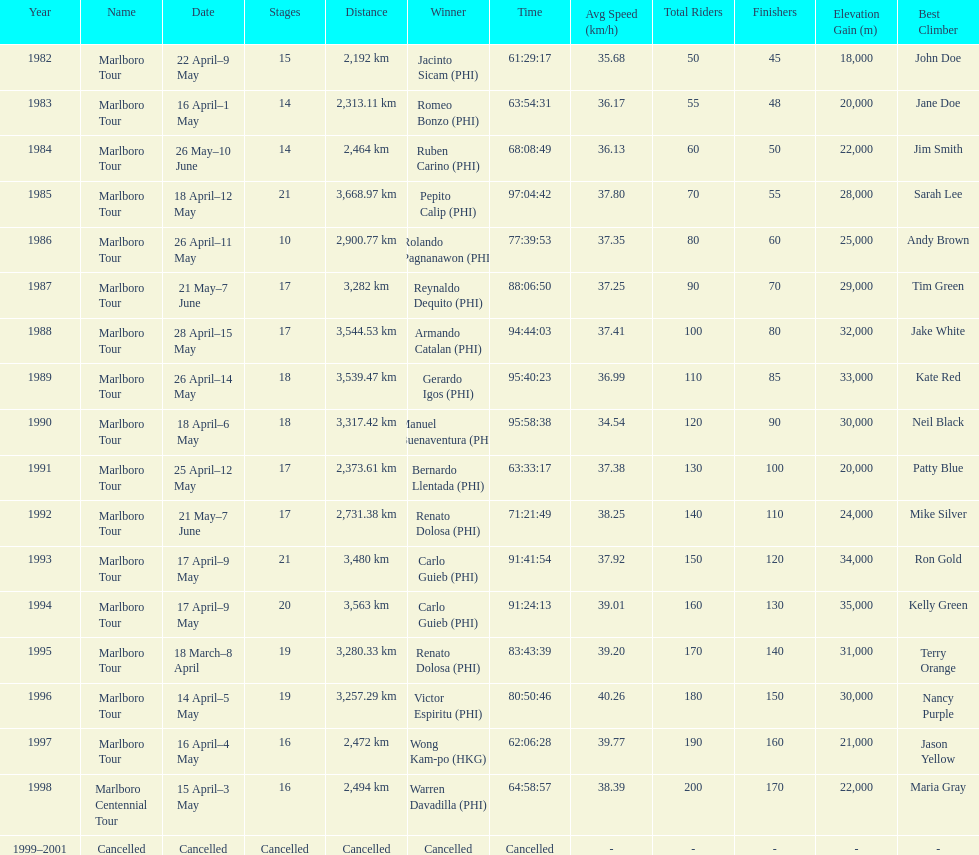Who is listed below romeo bonzo? Ruben Carino (PHI). 